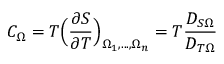<formula> <loc_0><loc_0><loc_500><loc_500>C _ { \Omega } = T \left ( \frac { \partial S } { \partial T } \right ) _ { \Omega _ { 1 } , \dots , \Omega _ { n } } = T \frac { D _ { S \Omega } } { D _ { T \Omega } }</formula> 